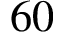<formula> <loc_0><loc_0><loc_500><loc_500>6 0</formula> 